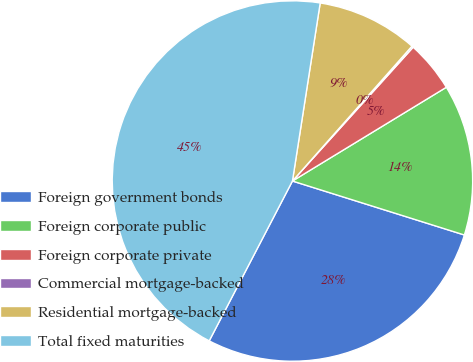Convert chart to OTSL. <chart><loc_0><loc_0><loc_500><loc_500><pie_chart><fcel>Foreign government bonds<fcel>Foreign corporate public<fcel>Foreign corporate private<fcel>Commercial mortgage-backed<fcel>Residential mortgage-backed<fcel>Total fixed maturities<nl><fcel>27.8%<fcel>13.55%<fcel>4.61%<fcel>0.14%<fcel>9.08%<fcel>44.82%<nl></chart> 